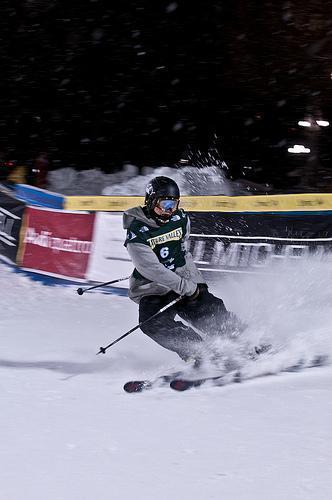How many people are in this picture?
Give a very brief answer. 1. How many different colored signs are on the fence?
Give a very brief answer. 3. 